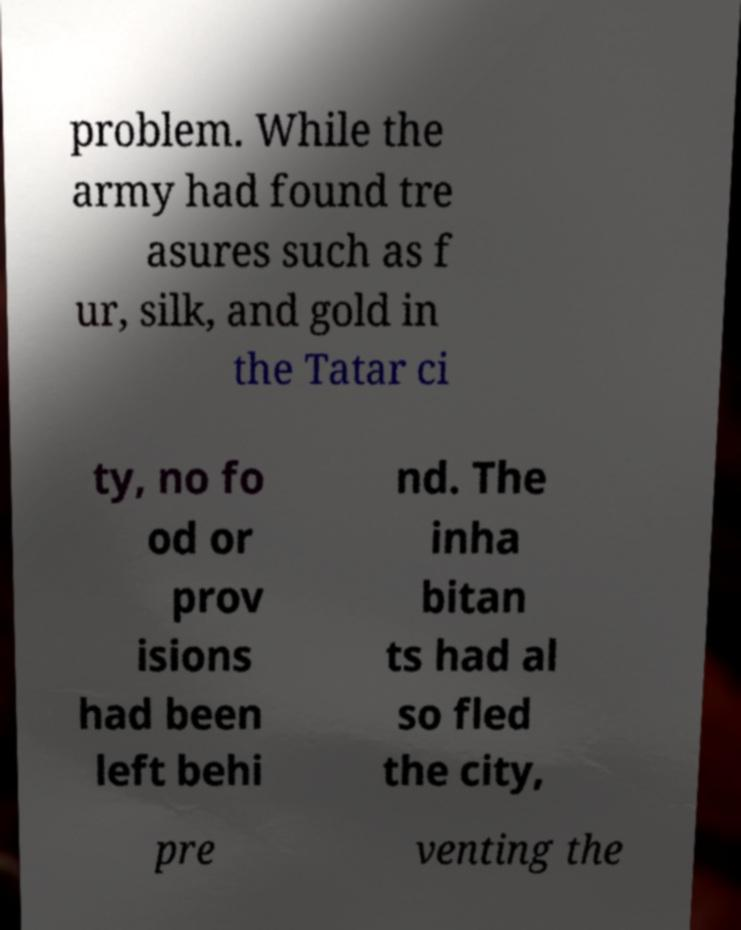Please identify and transcribe the text found in this image. problem. While the army had found tre asures such as f ur, silk, and gold in the Tatar ci ty, no fo od or prov isions had been left behi nd. The inha bitan ts had al so fled the city, pre venting the 